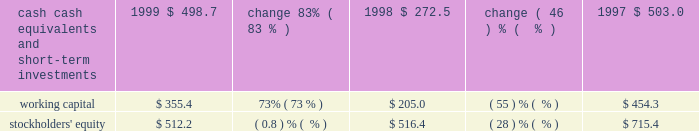Liquidity and capital resources .
Our cash , cash equivalents , and short-term investments consist principally of money market mutual funds , municipal bonds , and united states government agency securities .
All of our cash equivalents and short-term investments are classified as available-for-sale under the provisions of sfas 115 , 2018 2018accounting for certain investments in debt and equity securities . 2019 2019 the securities are carried at fair value with the unrealized gains and losses , net of tax , included in accumulated other comprehensive income , which is reflected as a separate component of stockholders 2019 equity .
Our cash , cash equivalents , and short-term investments increased $ 226.2 million , or 83% ( 83 % ) , in fiscal 1999 , primarily due to cash generated from operations of $ 334.2 million , proceeds from the issuance of treasury stock related to the exercise of stock options under our stock option plans and sale of stock under the employee stock purchase plan of $ 142.9 million , and the release of restricted funds totaling $ 130.3 million associated with the refinancing of our corporate headquarters lease agreement .
Other sources of cash include the proceeds from the sale of equity securities and the sale of a building in the amount of $ 63.9 million and $ 40.6 million , respectively .
In addition , short-term investments increased due to a reclassification of $ 46.7 million of investments classified as long-term to short-term as well as mark-to-market adjustments totaling $ 81.2 million .
These factors were partially offset by the purchase of treasury stock in the amount of $ 479.2 million , capital expenditures of $ 42.2 million , the purchase of other assets for $ 43.5 million , the purchase of the assets of golive systems and attitude software for $ 36.9 million , and the payment of dividends totaling $ 12.2 million .
We expect to continue our investing activities , including expenditures for computer systems for research and development , sales and marketing , product support , and administrative staff .
Furthermore , cash reserves may be used to purchase treasury stock and acquire software companies , products , or technologies that are complementary to our business .
In september 1997 , adobe 2019s board of directors authorized , subject to certain business and market conditions , the purchase of up to 30.0 million shares of our common stock over a two-year period .
We repurchased approximately 1.7 million shares in the first quarter of fiscal 1999 , 20.3 million shares in fiscal 1998 , and 8.0 million shares in fiscal 1997 , at a cost of $ 30.5 million , $ 362.4 million , and $ 188.6 million , respectively .
This program was completed during the first quarter of fiscal 1999 .
In april 1999 , adobe 2019s board of directors authorized , subject to certain business and market conditions , the purchase of up to an additional 5.0 million shares of our common stock over a two-year period .
This new stock repurchase program was in addition to an existing program whereby we have been authorized to repurchase shares to offset issuances under employee stock option and stock purchase plans .
No purchases have been made under the 5.0 million share repurchase program .
Under our existing plan to repurchase shares to offset issuances under employee stock plans , we repurchased approximately 11.2 million , 0.7 million , and 4.6 million shares in fiscal 1999 , 1998 , and 1997 , respectively , at a cost of $ 448.7 million , $ 16.8 million , and $ 87.0 million , respectively .
We have paid cash dividends on our common stock each quarter since the second quarter of 1988 .
Adobe 2019s board of directors declared a cash dividend on our common stock of $ 0.025 per common share for each of the four quarters in fiscal 1999 , 1998 , and 1997 .
On december 1 , 1997 , we dividended one share of siebel common stock for each 600 shares of adobe common stock held by stockholders of record on october 31 , 1997 .
An equivalent cash dividend was paid for holdings of less than 15000 adobe shares and .
Of the increase in short-term investments , how much was due to a reclassification of investments classified as long-term to short-term as well as mark-to-market adjustments ? 
Computations: (46.7 + 81.2)
Answer: 127.9. 